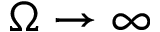Convert formula to latex. <formula><loc_0><loc_0><loc_500><loc_500>\Omega \to \infty</formula> 